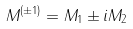Convert formula to latex. <formula><loc_0><loc_0><loc_500><loc_500>M ^ { ( \pm 1 ) } = M _ { 1 } \pm i M _ { 2 }</formula> 